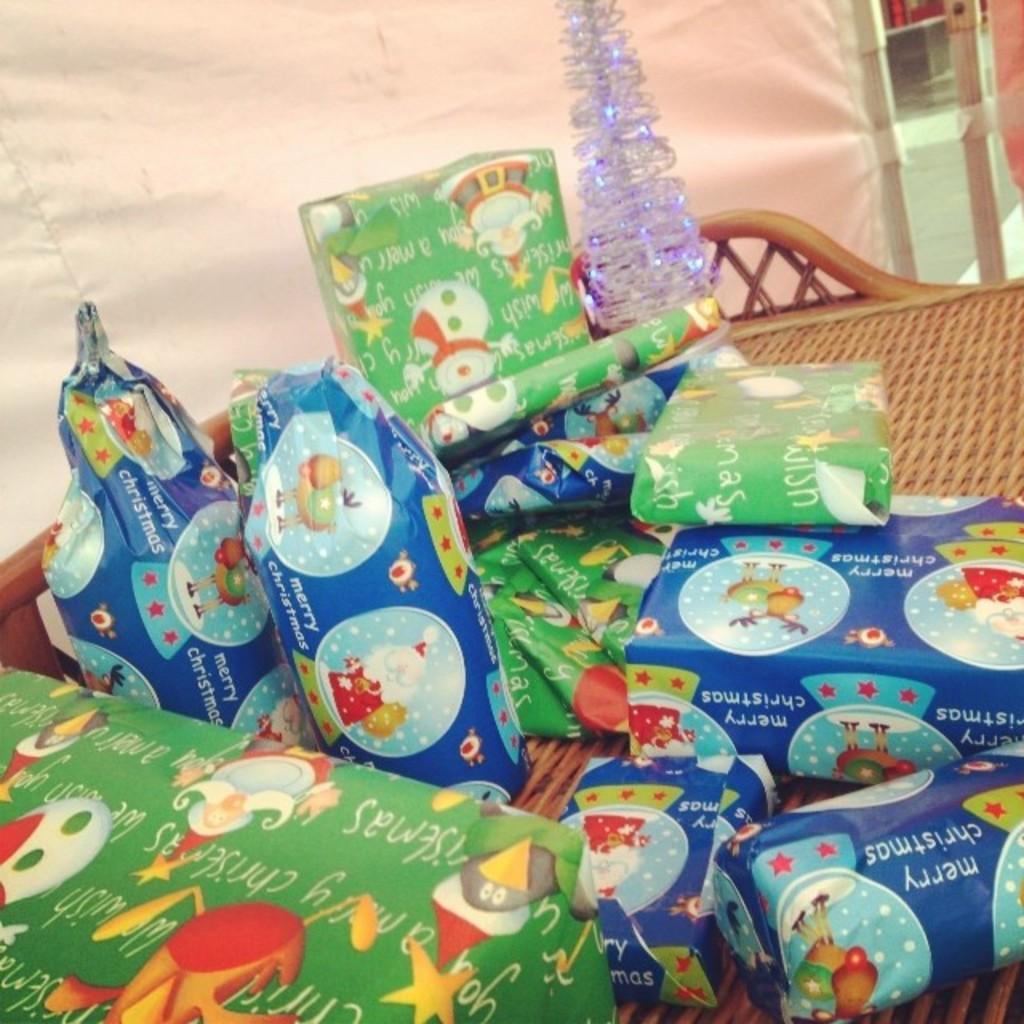Describe this image in one or two sentences. In this picture we can see an object, gift packets, basket, cloth and in the background we can see some objects. 